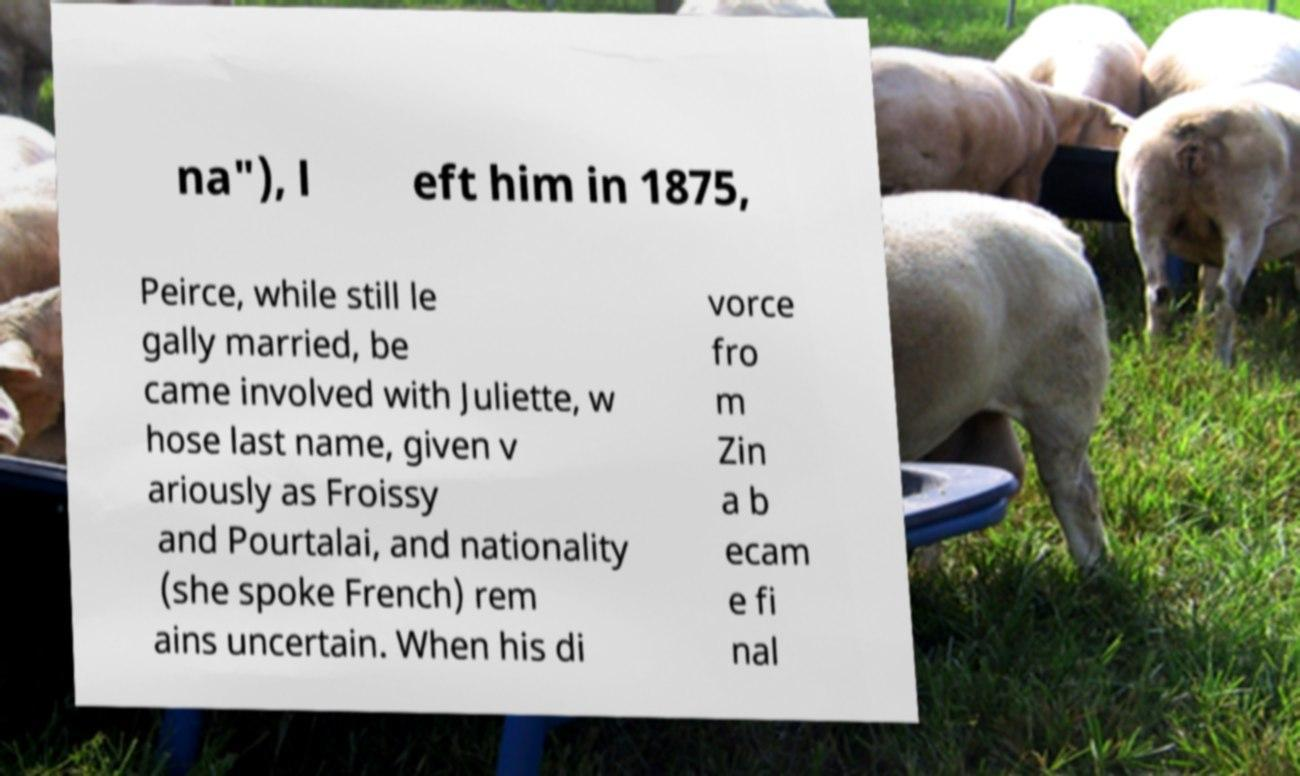Could you extract and type out the text from this image? na"), l eft him in 1875, Peirce, while still le gally married, be came involved with Juliette, w hose last name, given v ariously as Froissy and Pourtalai, and nationality (she spoke French) rem ains uncertain. When his di vorce fro m Zin a b ecam e fi nal 